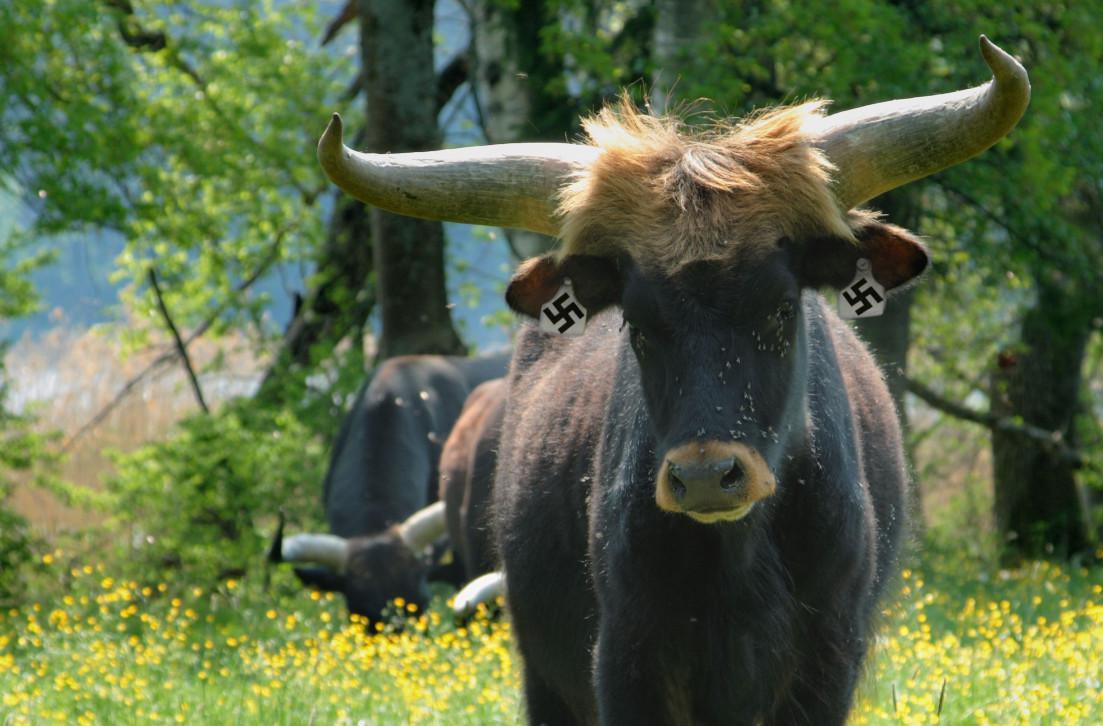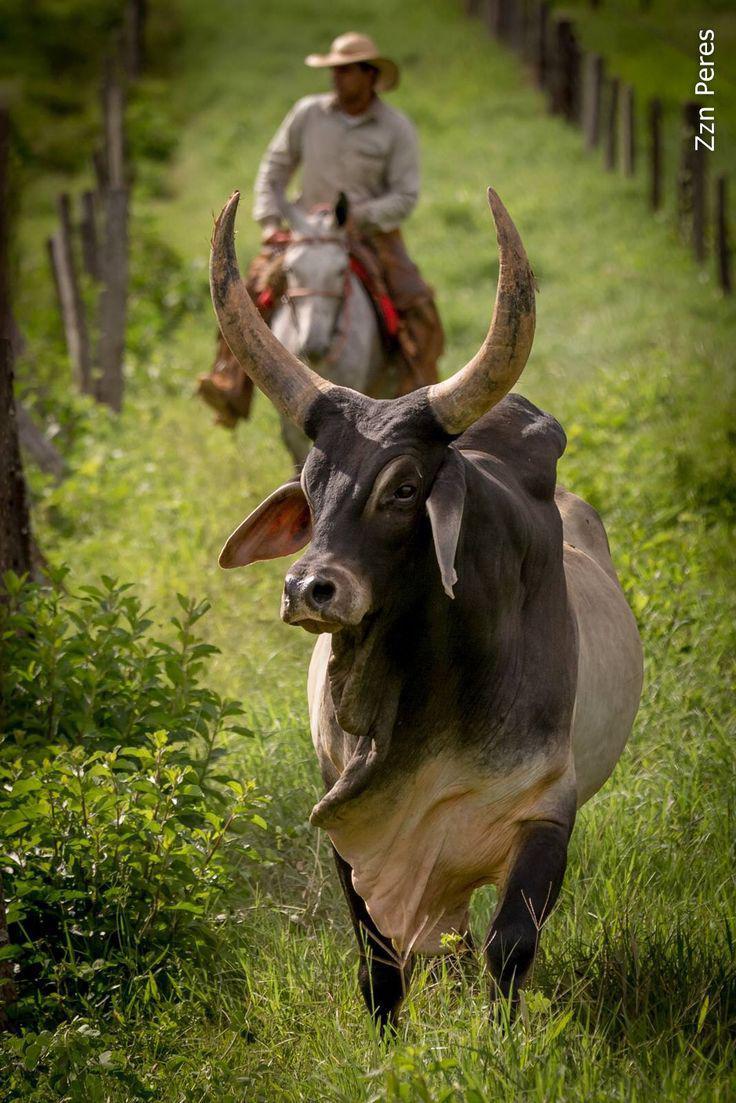The first image is the image on the left, the second image is the image on the right. Given the left and right images, does the statement "One of the animals is wearing decorations." hold true? Answer yes or no. Yes. The first image is the image on the left, the second image is the image on the right. Assess this claim about the two images: "The right image contains one forward-facing ox with a somewhat lowered head, and the left image shows two look-alike oxen standing on green grass.". Correct or not? Answer yes or no. No. 